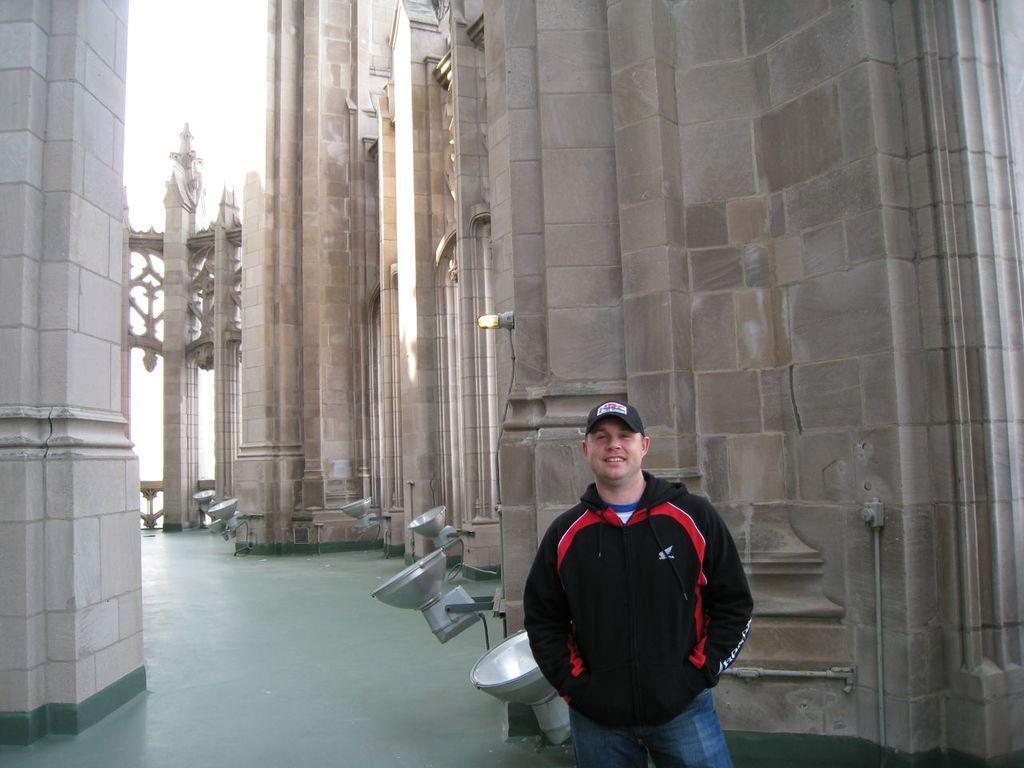Could you give a brief overview of what you see in this image? In this image, we can see a person standing and wearing a cap and a coat. In the background, there are lights and we can see a building. At the bottom, there is floor. 